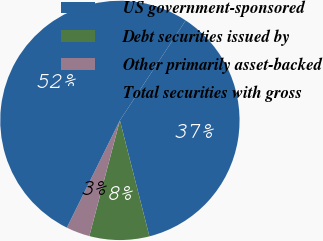<chart> <loc_0><loc_0><loc_500><loc_500><pie_chart><fcel>US government-sponsored<fcel>Debt securities issued by<fcel>Other primarily asset-backed<fcel>Total securities with gross<nl><fcel>36.77%<fcel>8.08%<fcel>3.2%<fcel>51.95%<nl></chart> 